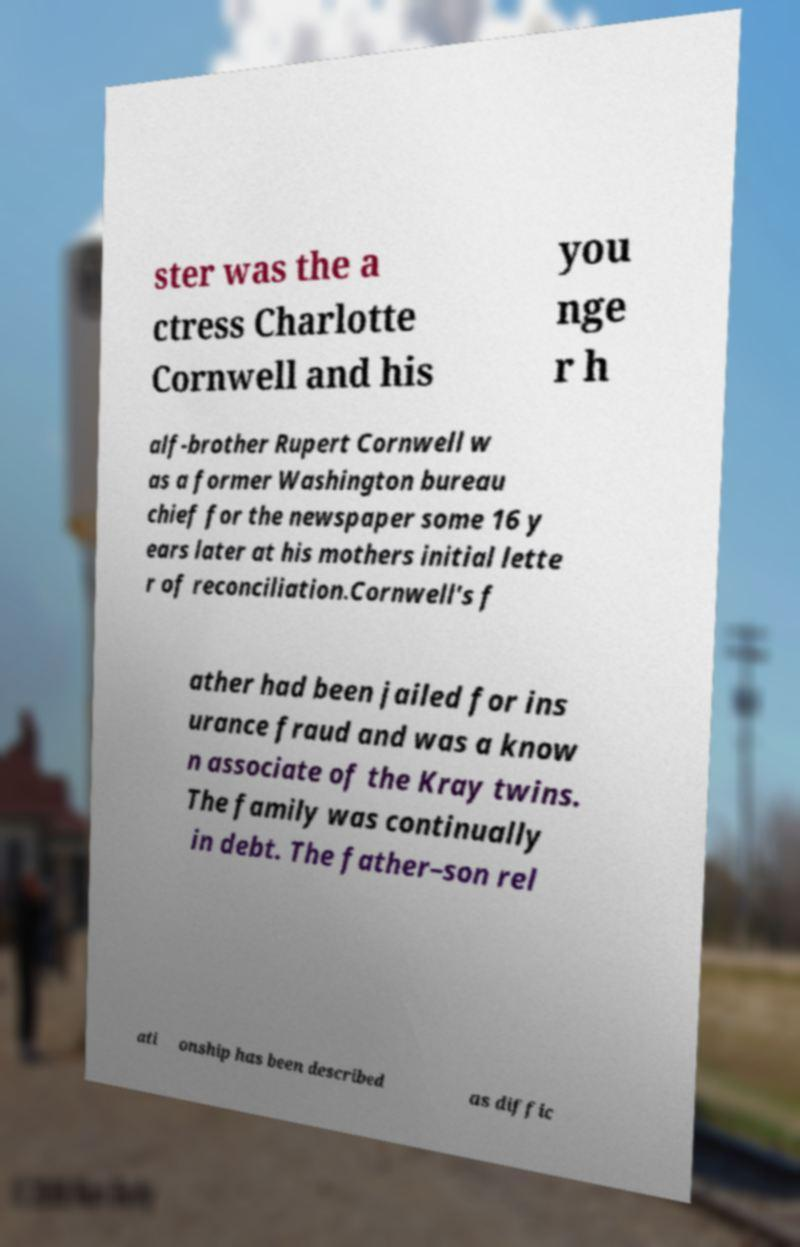What messages or text are displayed in this image? I need them in a readable, typed format. ster was the a ctress Charlotte Cornwell and his you nge r h alf-brother Rupert Cornwell w as a former Washington bureau chief for the newspaper some 16 y ears later at his mothers initial lette r of reconciliation.Cornwell's f ather had been jailed for ins urance fraud and was a know n associate of the Kray twins. The family was continually in debt. The father–son rel ati onship has been described as diffic 